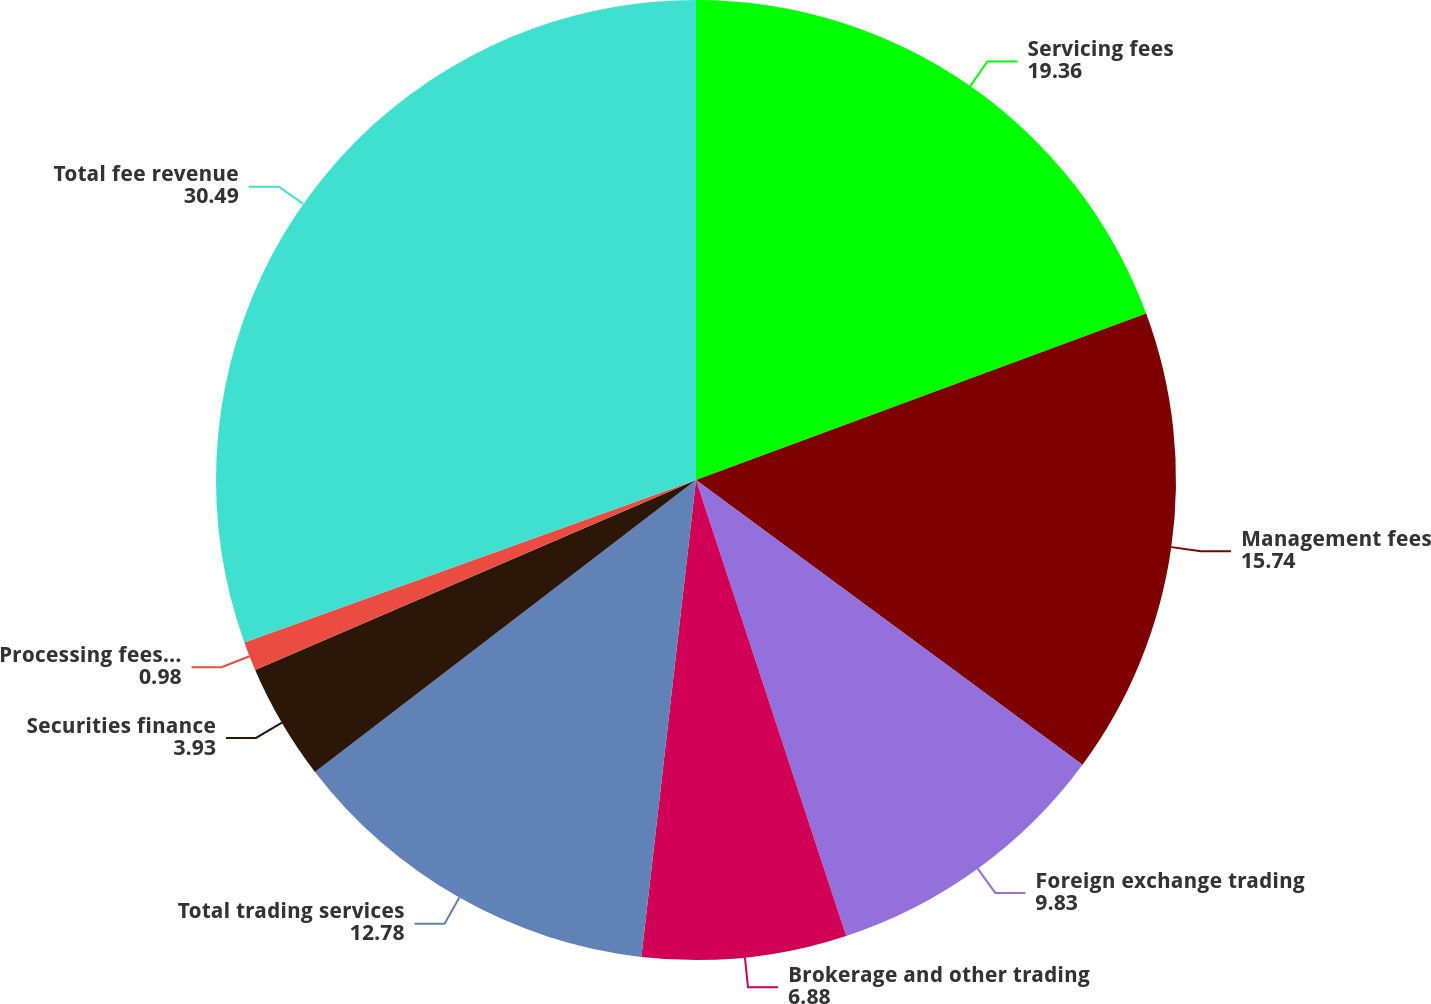Convert chart to OTSL. <chart><loc_0><loc_0><loc_500><loc_500><pie_chart><fcel>Servicing fees<fcel>Management fees<fcel>Foreign exchange trading<fcel>Brokerage and other trading<fcel>Total trading services<fcel>Securities finance<fcel>Processing fees and other<fcel>Total fee revenue<nl><fcel>19.36%<fcel>15.74%<fcel>9.83%<fcel>6.88%<fcel>12.78%<fcel>3.93%<fcel>0.98%<fcel>30.49%<nl></chart> 